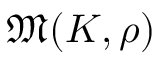Convert formula to latex. <formula><loc_0><loc_0><loc_500><loc_500>{ \mathfrak { M } } ( K , \rho )</formula> 